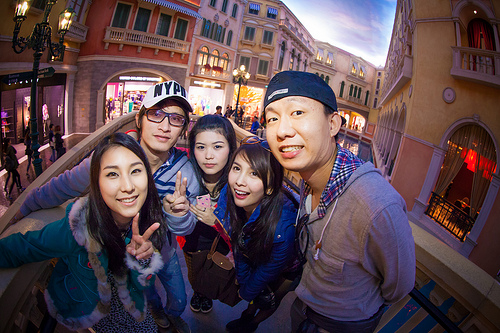<image>
Is there a hat on the woman? No. The hat is not positioned on the woman. They may be near each other, but the hat is not supported by or resting on top of the woman. Is the man to the left of the woman? Yes. From this viewpoint, the man is positioned to the left side relative to the woman. 